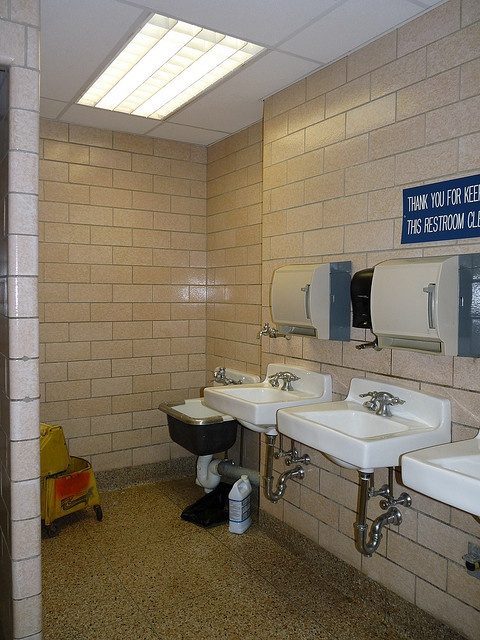Describe the objects in this image and their specific colors. I can see sink in gray, darkgray, and lightgray tones, sink in gray, darkgray, and lightgray tones, sink in gray, lightgray, and darkgray tones, and sink in gray, black, and darkgray tones in this image. 